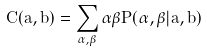<formula> <loc_0><loc_0><loc_500><loc_500>C ( \hat { a } , \hat { b } ) = \sum _ { \alpha , \beta } \alpha \beta P ( \alpha , \beta | \hat { a } , \hat { b } )</formula> 